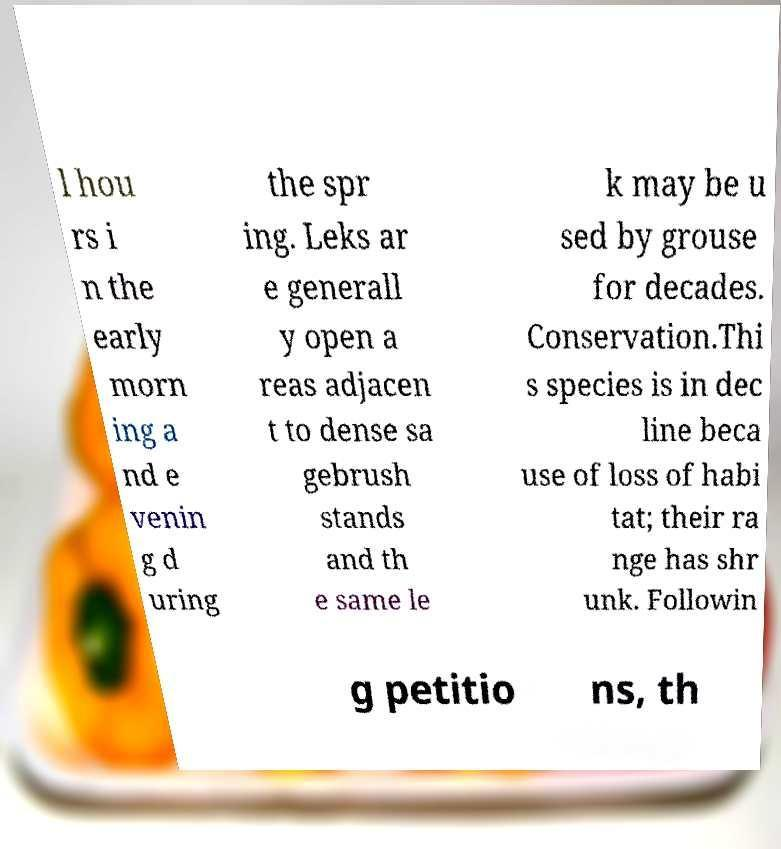Could you extract and type out the text from this image? l hou rs i n the early morn ing a nd e venin g d uring the spr ing. Leks ar e generall y open a reas adjacen t to dense sa gebrush stands and th e same le k may be u sed by grouse for decades. Conservation.Thi s species is in dec line beca use of loss of habi tat; their ra nge has shr unk. Followin g petitio ns, th 